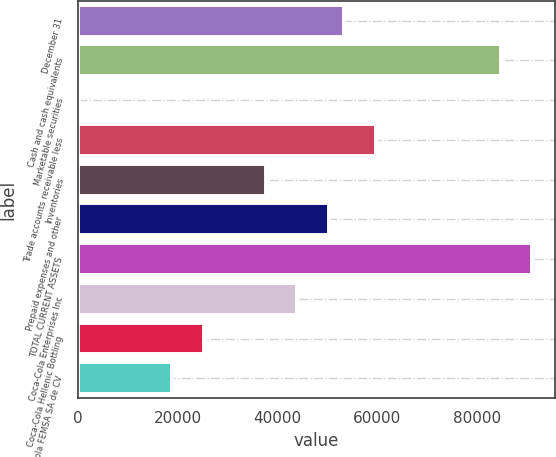Convert chart to OTSL. <chart><loc_0><loc_0><loc_500><loc_500><bar_chart><fcel>December 31<fcel>Cash and cash equivalents<fcel>Marketable securities<fcel>Trade accounts receivable less<fcel>Inventories<fcel>Prepaid expenses and other<fcel>TOTAL CURRENT ASSETS<fcel>Coca-Cola Enterprises Inc<fcel>Coca-Cola Hellenic Bottling<fcel>Coca-Cola FEMSA SA de CV<nl><fcel>53407<fcel>84787<fcel>61<fcel>59683<fcel>37717<fcel>50269<fcel>91063<fcel>43993<fcel>25165<fcel>18889<nl></chart> 